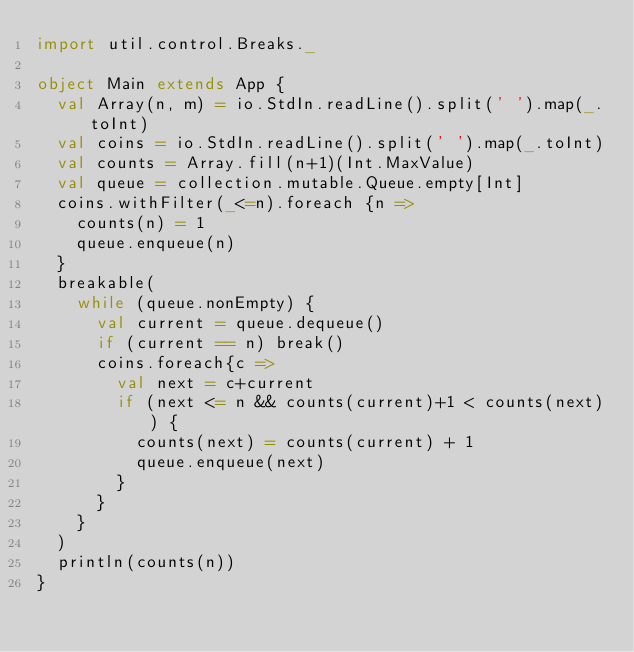<code> <loc_0><loc_0><loc_500><loc_500><_Scala_>import util.control.Breaks._

object Main extends App {
  val Array(n, m) = io.StdIn.readLine().split(' ').map(_.toInt)
  val coins = io.StdIn.readLine().split(' ').map(_.toInt)
  val counts = Array.fill(n+1)(Int.MaxValue)
  val queue = collection.mutable.Queue.empty[Int]
  coins.withFilter(_<=n).foreach {n =>
    counts(n) = 1
    queue.enqueue(n)
  }
  breakable(
    while (queue.nonEmpty) {
      val current = queue.dequeue()
      if (current == n) break()
      coins.foreach{c =>
        val next = c+current
        if (next <= n && counts(current)+1 < counts(next)) {
          counts(next) = counts(current) + 1
          queue.enqueue(next)
        }
      }
    }
  )
  println(counts(n))
}
</code> 